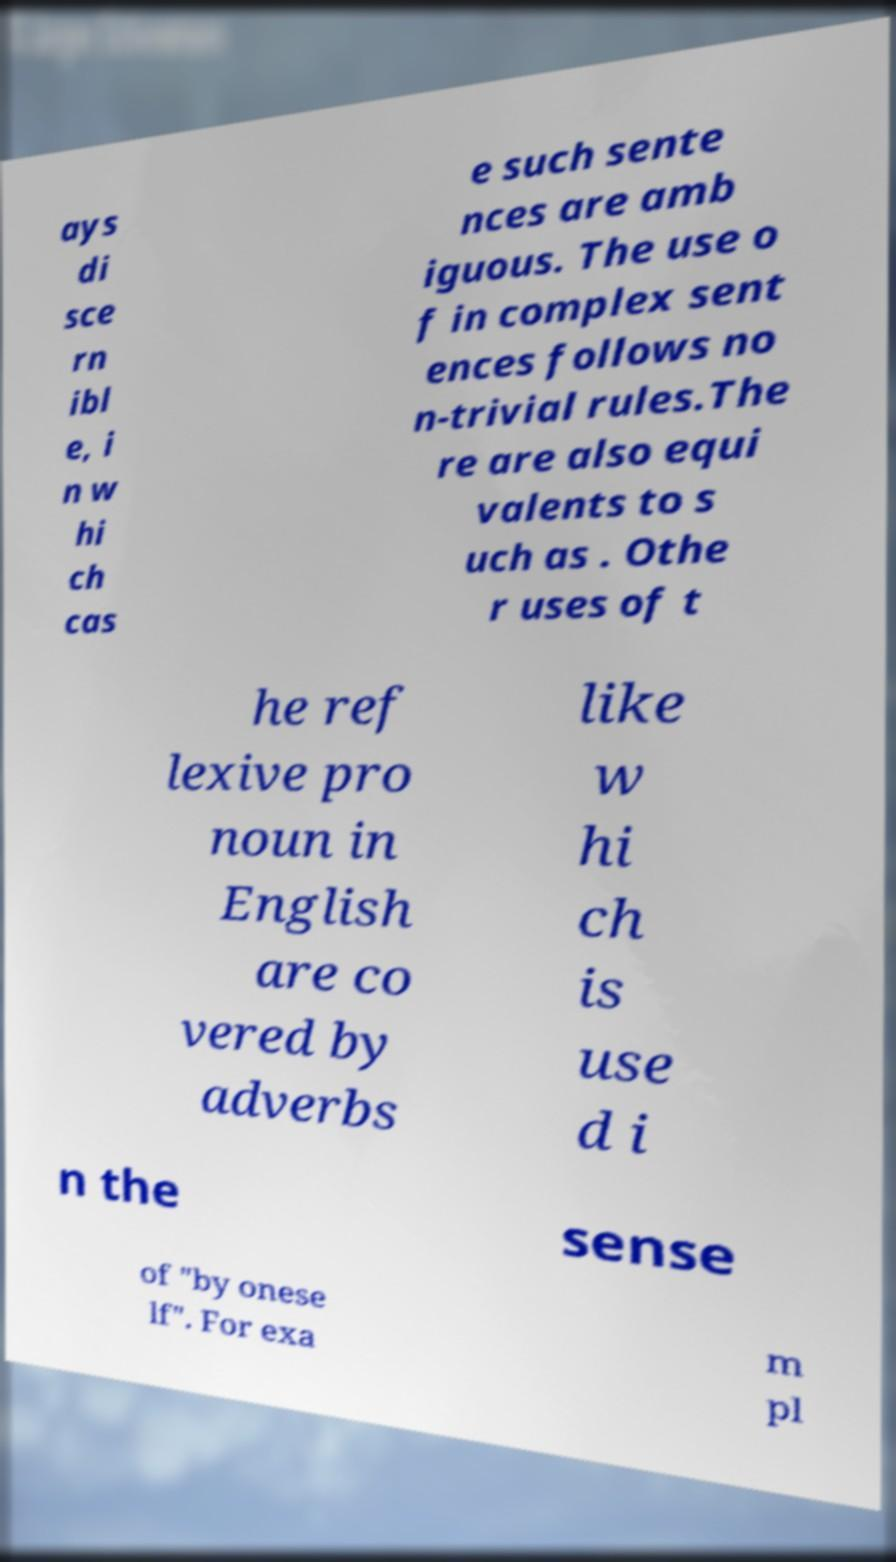Can you read and provide the text displayed in the image?This photo seems to have some interesting text. Can you extract and type it out for me? ays di sce rn ibl e, i n w hi ch cas e such sente nces are amb iguous. The use o f in complex sent ences follows no n-trivial rules.The re are also equi valents to s uch as . Othe r uses of t he ref lexive pro noun in English are co vered by adverbs like w hi ch is use d i n the sense of "by onese lf". For exa m pl 